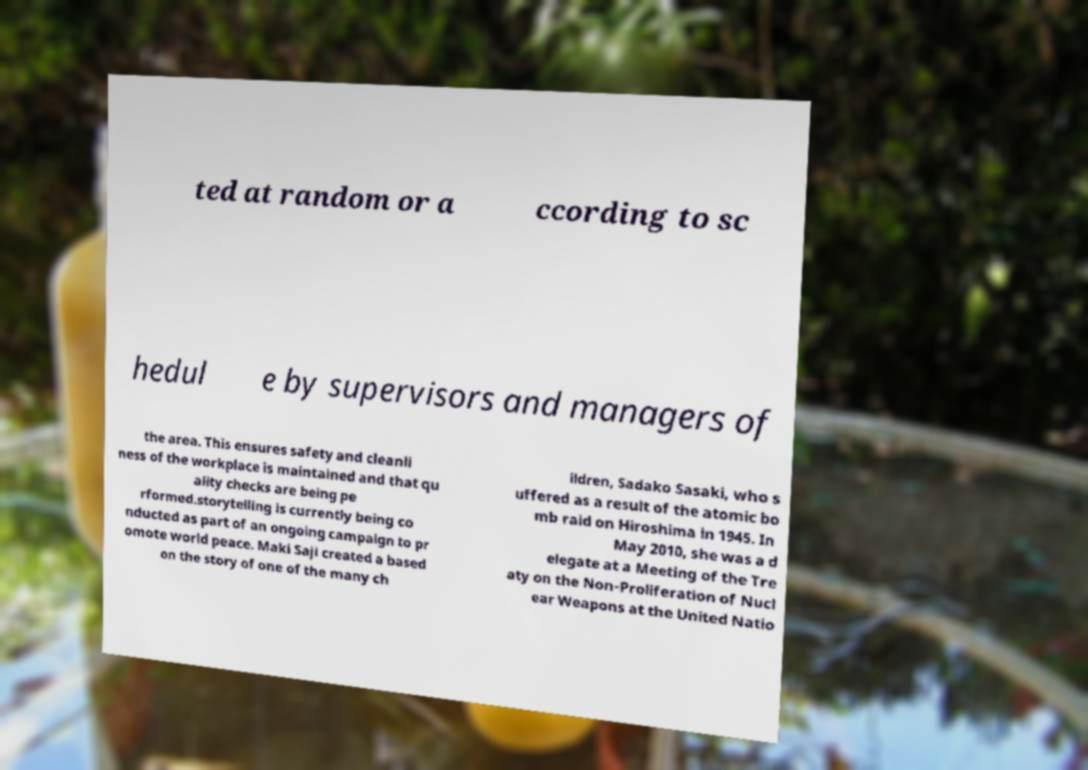Can you read and provide the text displayed in the image?This photo seems to have some interesting text. Can you extract and type it out for me? ted at random or a ccording to sc hedul e by supervisors and managers of the area. This ensures safety and cleanli ness of the workplace is maintained and that qu ality checks are being pe rformed.storytelling is currently being co nducted as part of an ongoing campaign to pr omote world peace. Maki Saji created a based on the story of one of the many ch ildren, Sadako Sasaki, who s uffered as a result of the atomic bo mb raid on Hiroshima in 1945. In May 2010, she was a d elegate at a Meeting of the Tre aty on the Non-Proliferation of Nucl ear Weapons at the United Natio 